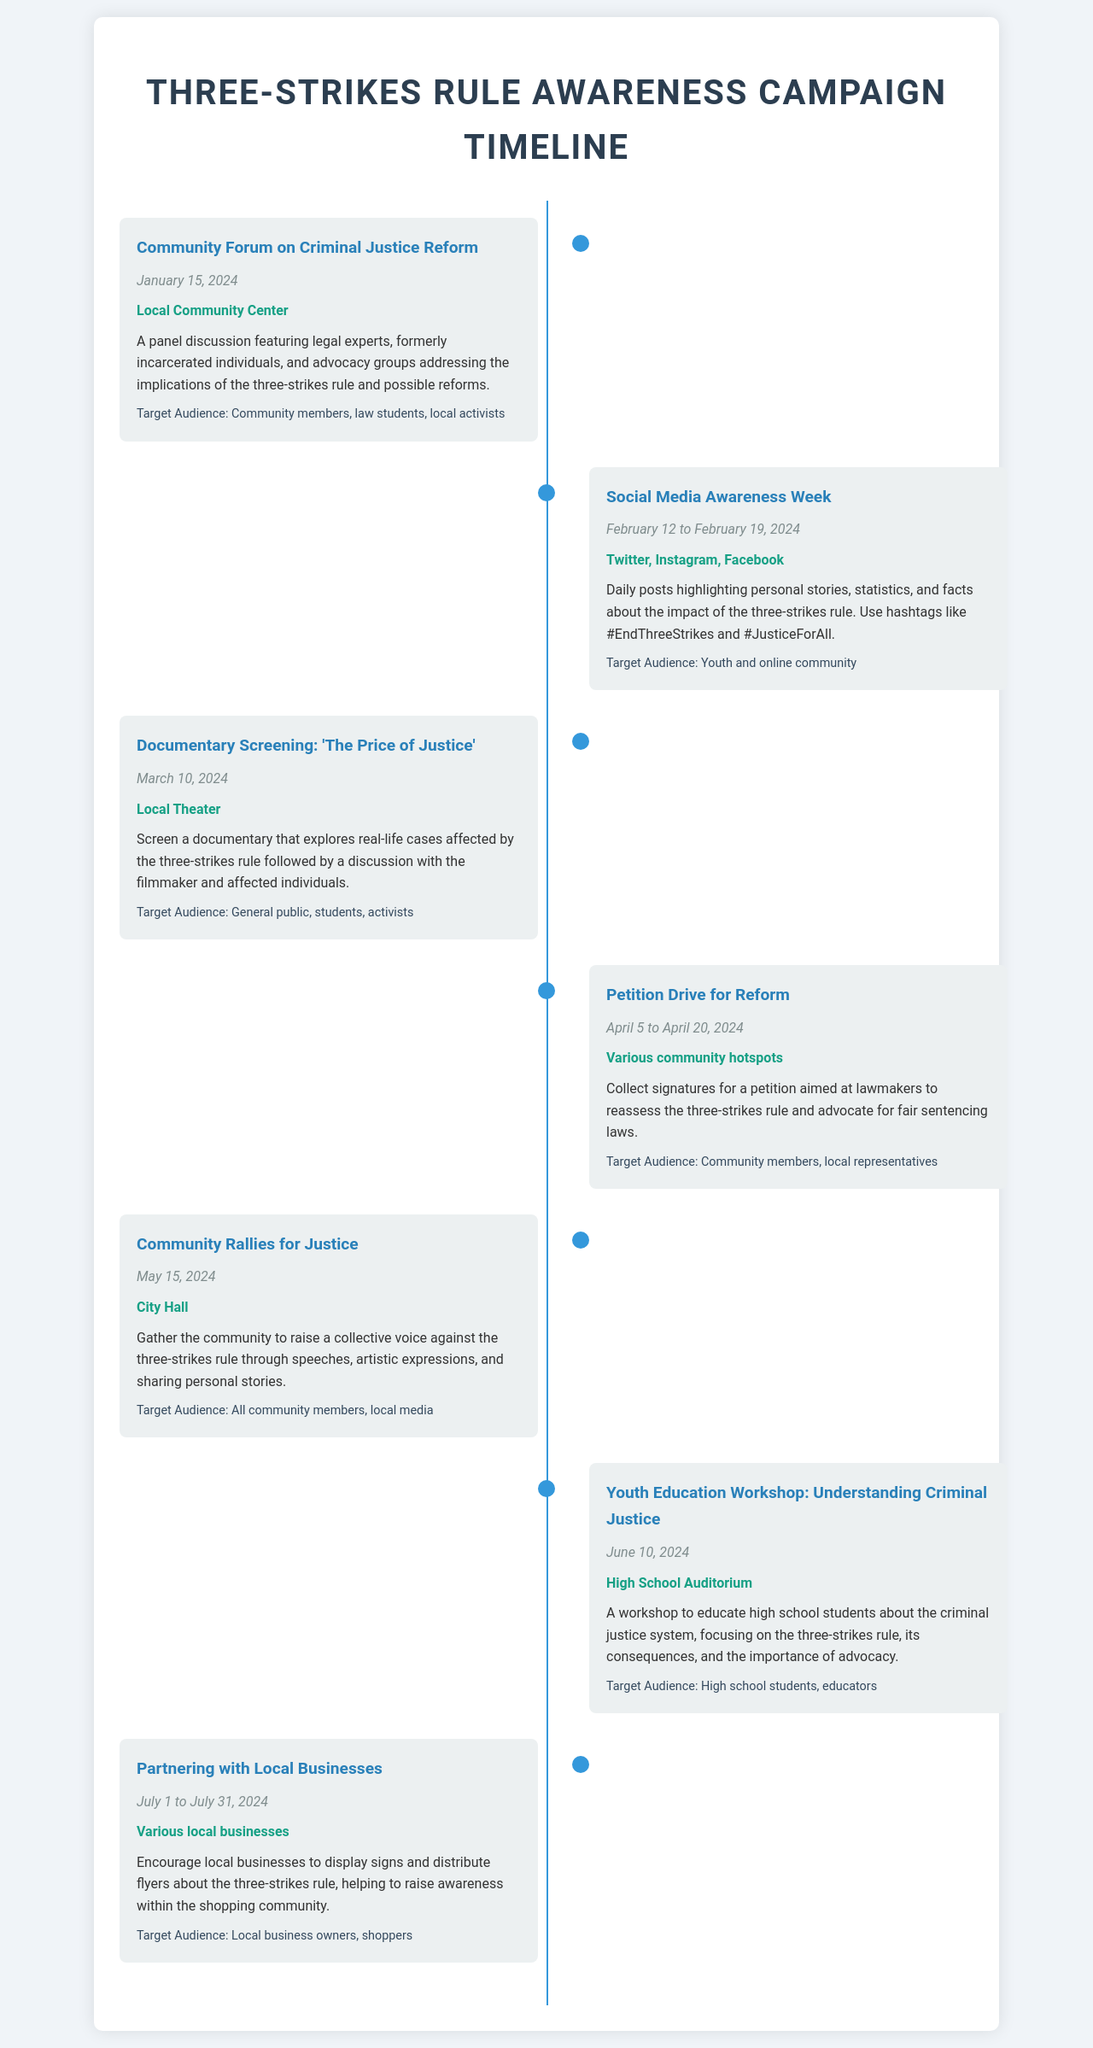What is the date of the Community Forum? The date is listed in the event description of the Community Forum.
Answer: January 15, 2024 What is the location of the Social Media Awareness Week? The location for this event is found in the event details for Social Media Awareness Week.
Answer: Twitter, Instagram, Facebook What is the main focus of the documentary being screened? The focus of the documentary is mentioned in the description of the Documentary Screening event.
Answer: Real-life cases affected by the three-strikes rule How long will the Petition Drive for Reform last? The duration is provided in the event details of the Petition Drive.
Answer: 15 days What type of audience is targeted for the Youth Education Workshop? The target audience is specified in the Youth Education Workshop details.
Answer: High school students, educators Which event takes place at City Hall? The location is found in the description of the Community Rallies for Justice event.
Answer: Community Rallies for Justice How many days does the Partnering with Local Businesses last? The duration is indicated in the event details for Partnering with Local Businesses.
Answer: 31 days What is the main objective of the Community Rallies for Justice? The objective is detailed in the event description for the Community Rallies for Justice.
Answer: Raise a collective voice against the three-strikes rule 